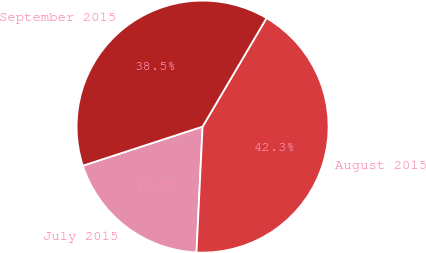Convert chart. <chart><loc_0><loc_0><loc_500><loc_500><pie_chart><fcel>July 2015<fcel>August 2015<fcel>September 2015<nl><fcel>19.21%<fcel>42.3%<fcel>38.5%<nl></chart> 